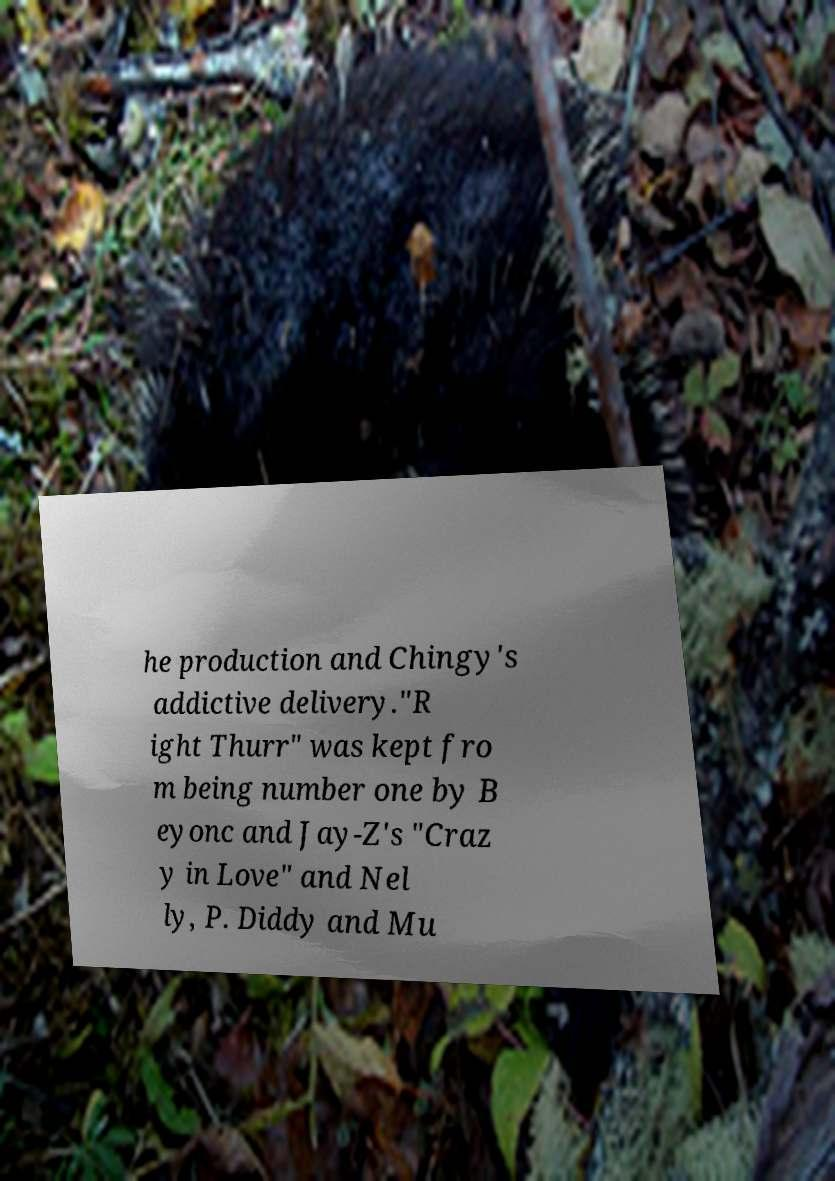I need the written content from this picture converted into text. Can you do that? he production and Chingy's addictive delivery."R ight Thurr" was kept fro m being number one by B eyonc and Jay-Z's "Craz y in Love" and Nel ly, P. Diddy and Mu 